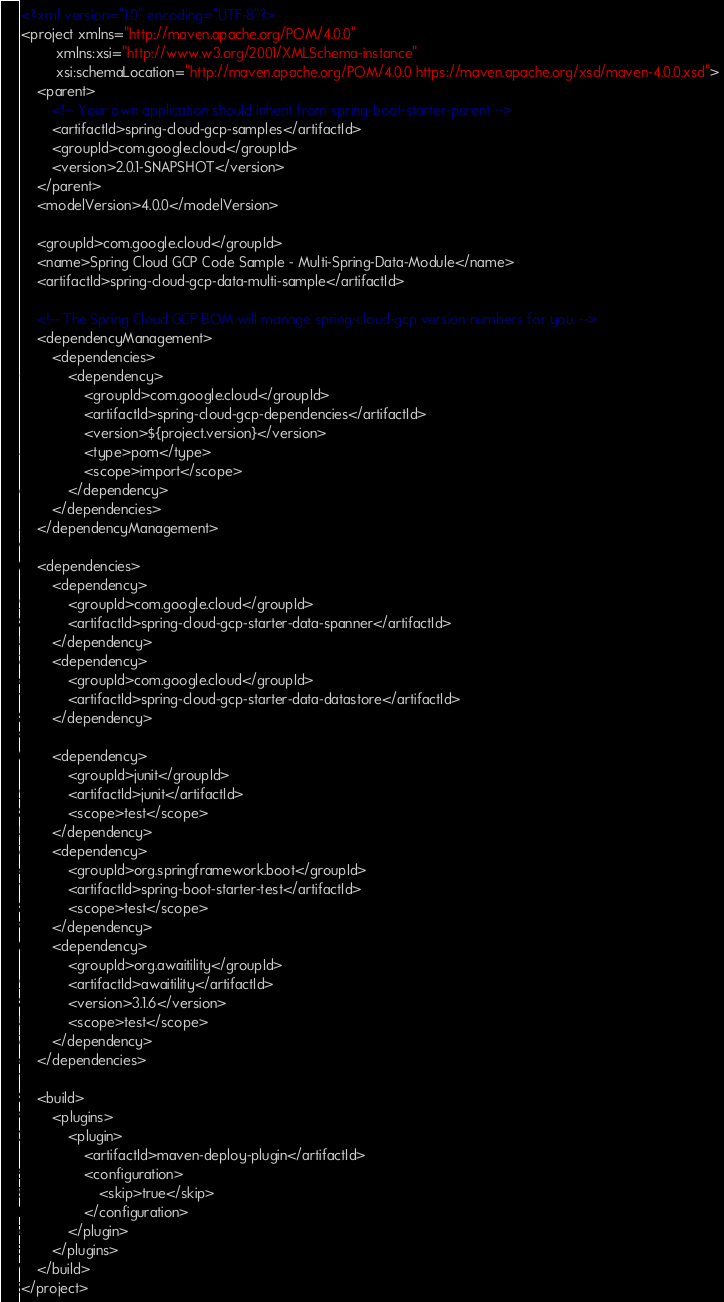<code> <loc_0><loc_0><loc_500><loc_500><_XML_><?xml version="1.0" encoding="UTF-8"?>
<project xmlns="http://maven.apache.org/POM/4.0.0"
         xmlns:xsi="http://www.w3.org/2001/XMLSchema-instance"
         xsi:schemaLocation="http://maven.apache.org/POM/4.0.0 https://maven.apache.org/xsd/maven-4.0.0.xsd">
    <parent>
        <!-- Your own application should inherit from spring-boot-starter-parent -->
        <artifactId>spring-cloud-gcp-samples</artifactId>
        <groupId>com.google.cloud</groupId>
        <version>2.0.1-SNAPSHOT</version>
    </parent>
    <modelVersion>4.0.0</modelVersion>

    <groupId>com.google.cloud</groupId>
    <name>Spring Cloud GCP Code Sample - Multi-Spring-Data-Module</name>
    <artifactId>spring-cloud-gcp-data-multi-sample</artifactId>

    <!-- The Spring Cloud GCP BOM will manage spring-cloud-gcp version numbers for you. -->
    <dependencyManagement>
        <dependencies>
            <dependency>
                <groupId>com.google.cloud</groupId>
                <artifactId>spring-cloud-gcp-dependencies</artifactId>
                <version>${project.version}</version>
                <type>pom</type>
                <scope>import</scope>
            </dependency>
        </dependencies>
    </dependencyManagement>

    <dependencies>
        <dependency>
            <groupId>com.google.cloud</groupId>
            <artifactId>spring-cloud-gcp-starter-data-spanner</artifactId>
        </dependency>
        <dependency>
            <groupId>com.google.cloud</groupId>
            <artifactId>spring-cloud-gcp-starter-data-datastore</artifactId>
        </dependency>

        <dependency>
            <groupId>junit</groupId>
            <artifactId>junit</artifactId>
            <scope>test</scope>
        </dependency>
        <dependency>
            <groupId>org.springframework.boot</groupId>
            <artifactId>spring-boot-starter-test</artifactId>
            <scope>test</scope>
        </dependency>
        <dependency>
            <groupId>org.awaitility</groupId>
            <artifactId>awaitility</artifactId>
            <version>3.1.6</version>
            <scope>test</scope>
        </dependency>
    </dependencies>

    <build>
        <plugins>
            <plugin>
                <artifactId>maven-deploy-plugin</artifactId>
                <configuration>
                    <skip>true</skip>
                </configuration>
            </plugin>
        </plugins>
    </build>
</project>
</code> 